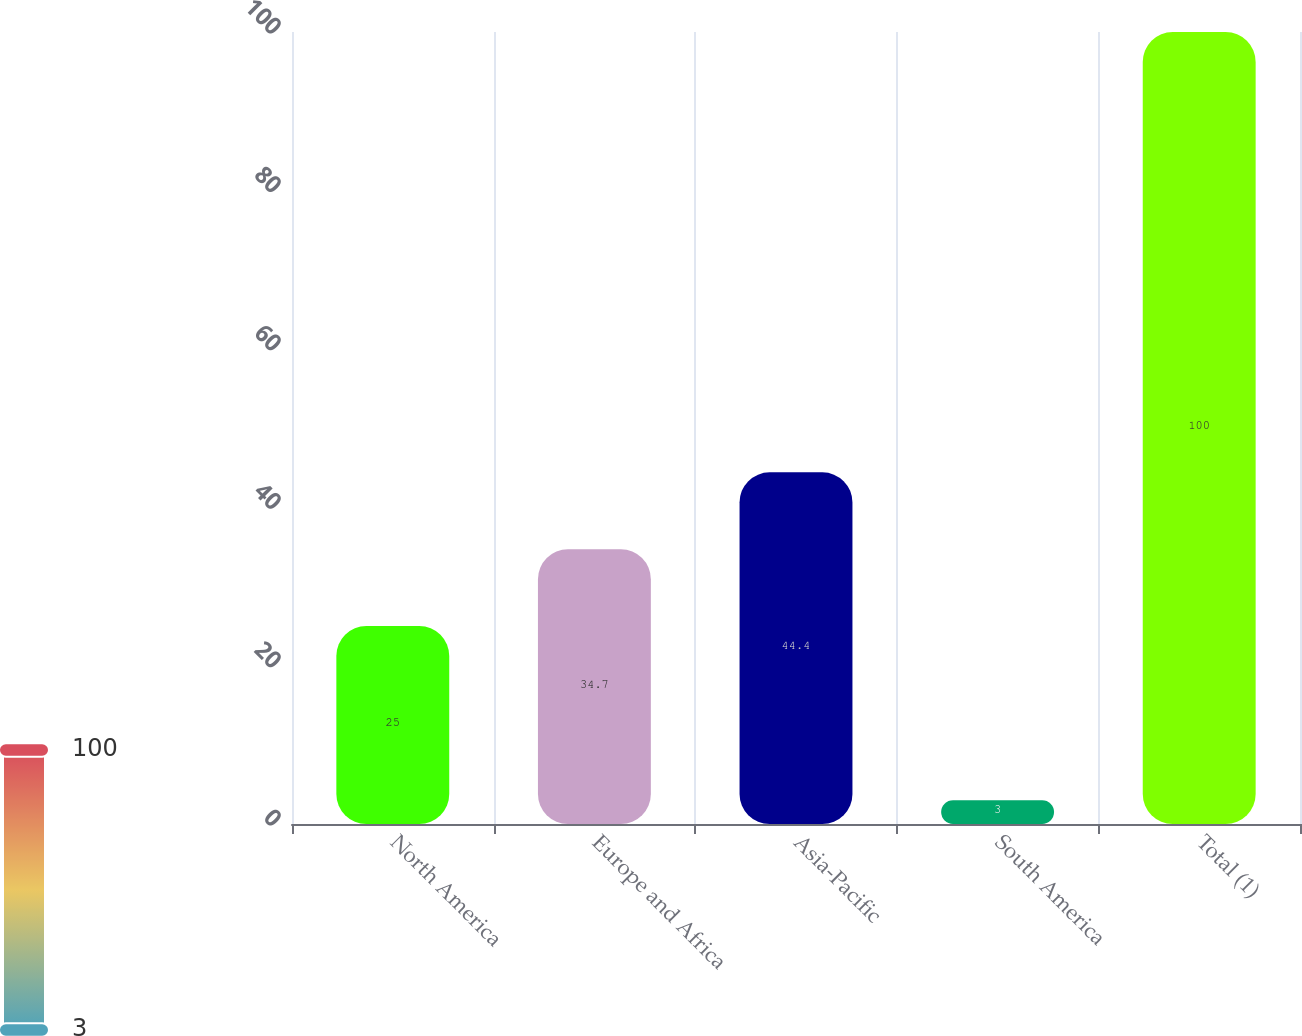Convert chart to OTSL. <chart><loc_0><loc_0><loc_500><loc_500><bar_chart><fcel>North America<fcel>Europe and Africa<fcel>Asia-Pacific<fcel>South America<fcel>Total (1)<nl><fcel>25<fcel>34.7<fcel>44.4<fcel>3<fcel>100<nl></chart> 